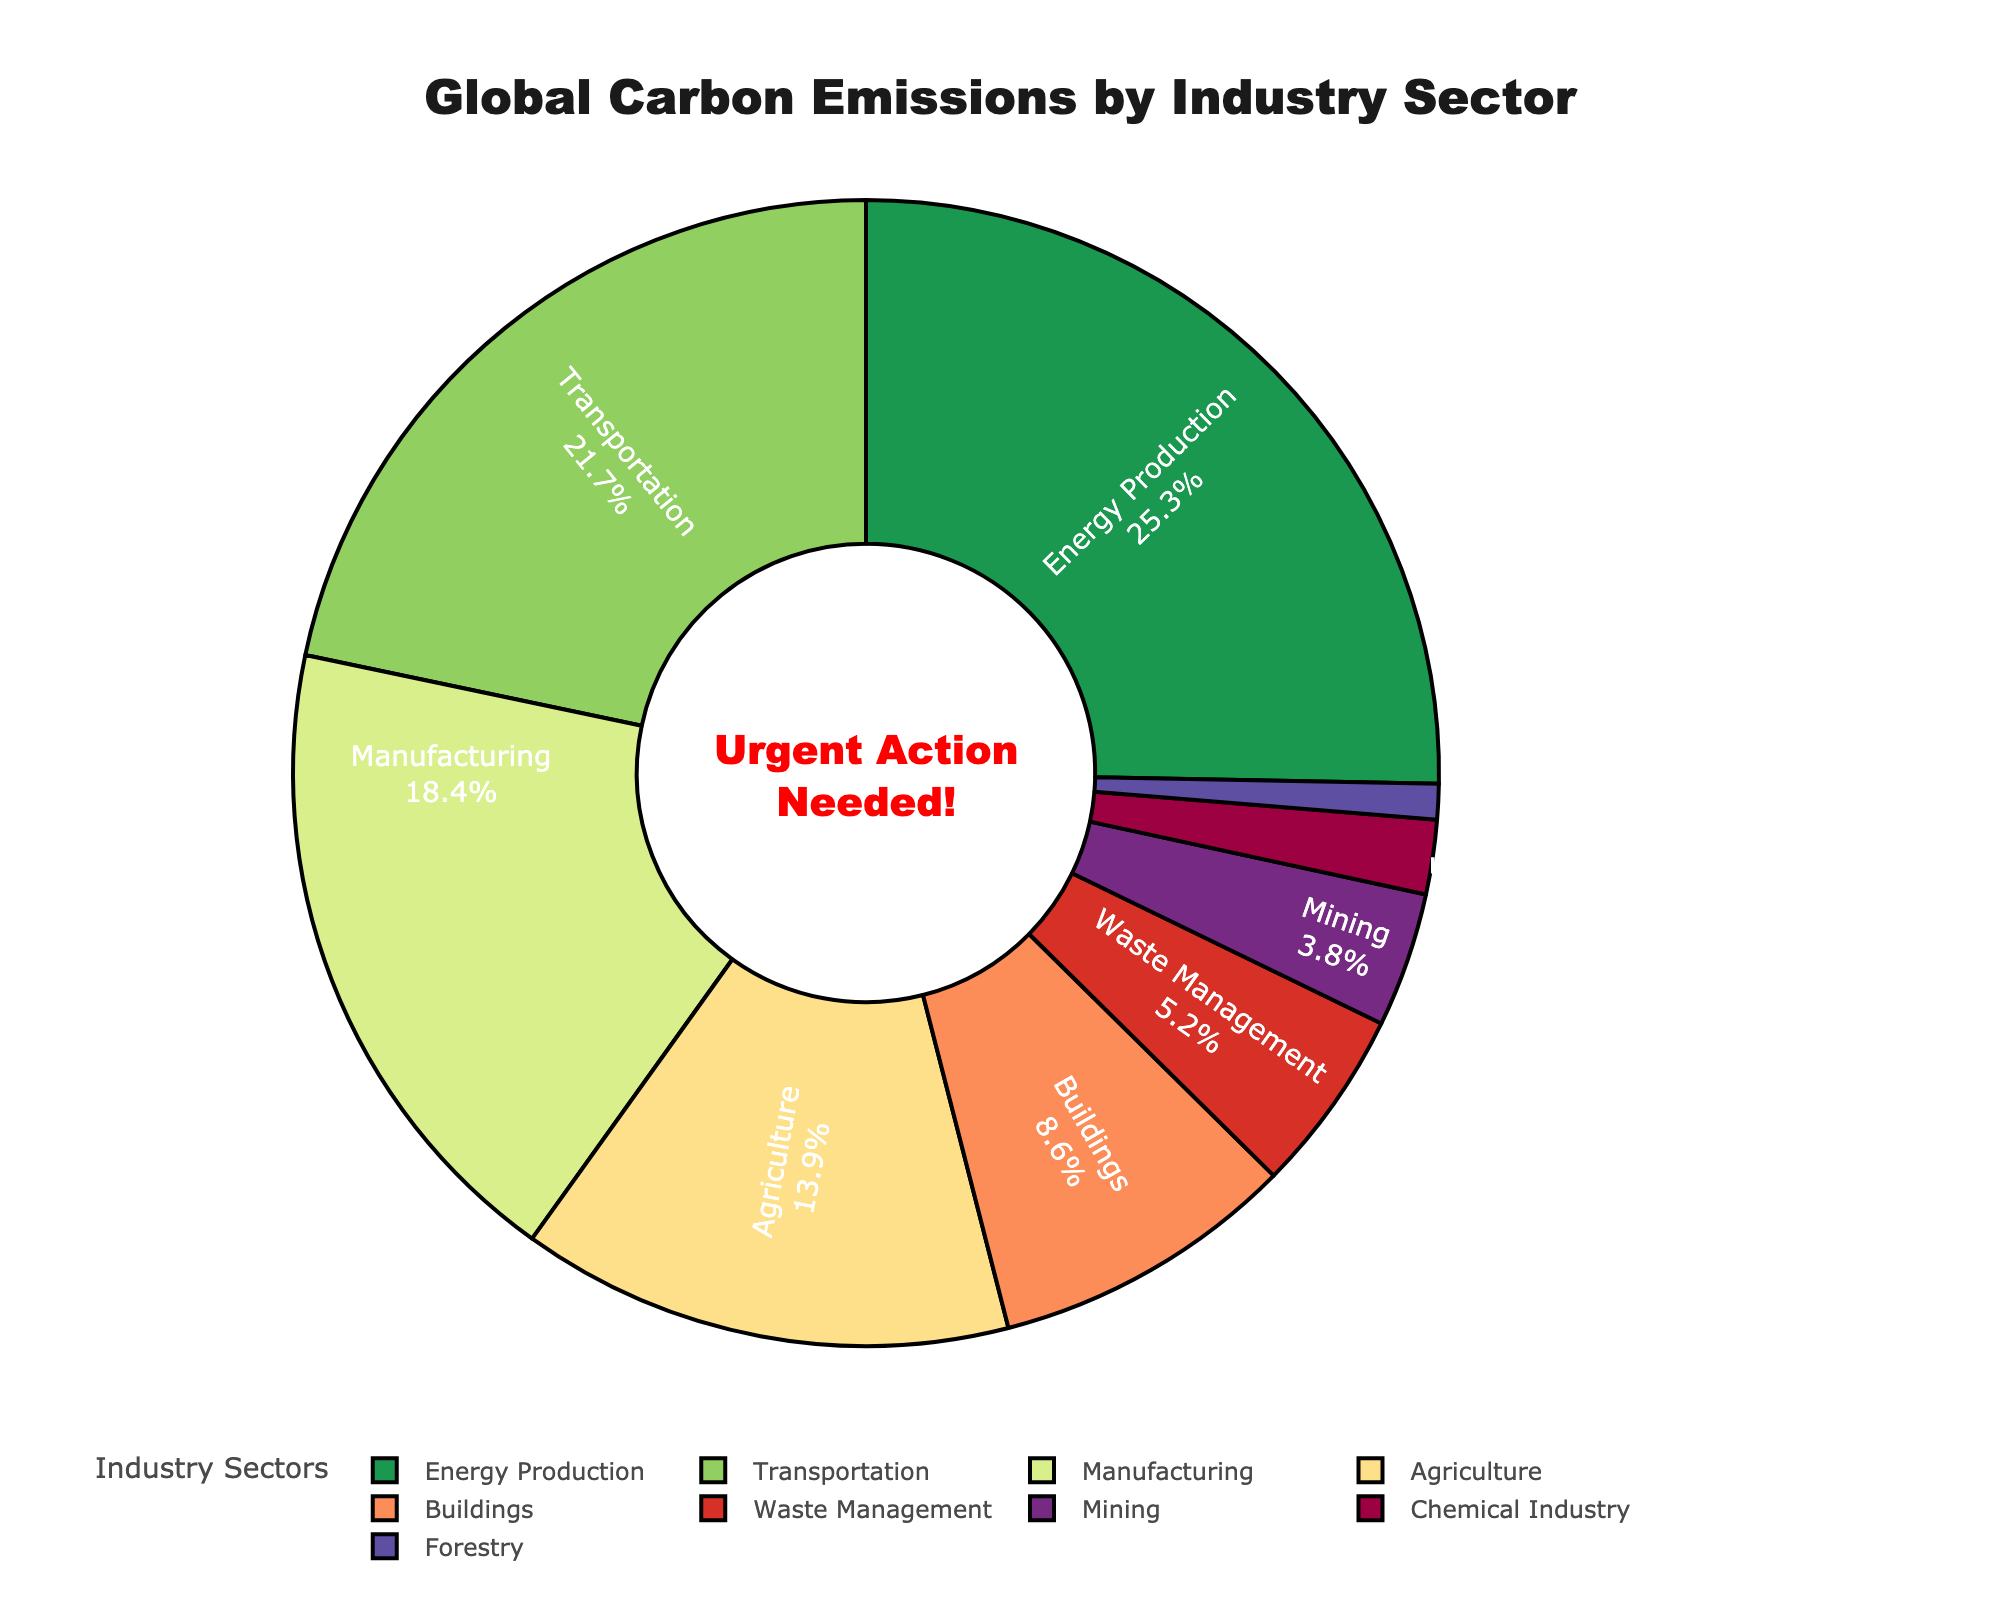What industry sector contributes the largest percentage of global carbon emissions? By looking at the labeled percentages in the pie chart, we identify the sector with the largest percentage. "Energy Production" holds the largest portion with 25.3%.
Answer: Energy Production How much higher is the carbon emission percentage of Energy Production compared to Forestry? Subtract the percentage of Forestry (1.0%) from Energy Production (25.3%). The difference is 25.3 - 1.0 = 24.3%.
Answer: 24.3% What is the combined percentage of carbon emissions from Agriculture and Manufacturing? Add the percentages of Agriculture (13.9%) and Manufacturing (18.4%). The combined percentage is 13.9 + 18.4 = 32.3%.
Answer: 32.3% Which sector has a higher percentage of carbon emissions: Buildings or Waste Management? Compare the percentages of Buildings (8.6%) and Waste Management (5.2%). Buildings have a higher percentage.
Answer: Buildings What is the ratio of carbon emissions between Transportation and Mining? To find the ratio, divide the percentage of Transportation (21.7%) by Mining (3.8%). The ratio is 21.7 / 3.8 ≈ 5.7.
Answer: 5.7 Is the percentage of carbon emissions from Manufacturing closer to that of Energy Production or Transportation? Compare the differences: Manufacturing to Energy Production (25.3 - 18.4 = 6.9) and Manufacturing to Transportation (21.7 - 18.4 = 3.3). The smaller difference indicates it is closer to Transportation.
Answer: Transportation What is the total percentage of carbon emissions contributed by Waste Management, Mining, and the Chemical Industry combined? Add the percentages of Waste Management (5.2%), Mining (3.8%), and the Chemical Industry (2.1%). The total is 5.2 + 3.8 + 2.1 = 11.1%.
Answer: 11.1% How does the percentage of carbon emissions from Agriculture compare to Buildings visually? Agriculture is represented as a larger slice in the pie chart compared to Buildings. Numerically, Agriculture (13.9%) is larger than Buildings (8.6%).
Answer: Agriculture is larger What percentage of carbon emissions is contributed by sectors other than Energy Production, Transportation, and Manufacturing? Sum the percentages of Energy Production, Transportation, and Manufacturing, then subtract from 100%: 25.3 + 21.7 + 18.4 = 65.4, 100 - 65.4 = 34.6%.
Answer: 34.6% If the overall carbon emissions were to be reduced by half, how much percentage would Agriculture contribute in that scenario? Agriculture's current percentage is 13.9%. If overall emissions are halved, the relative percentage of Agriculture remains the same.
Answer: 13.9% 